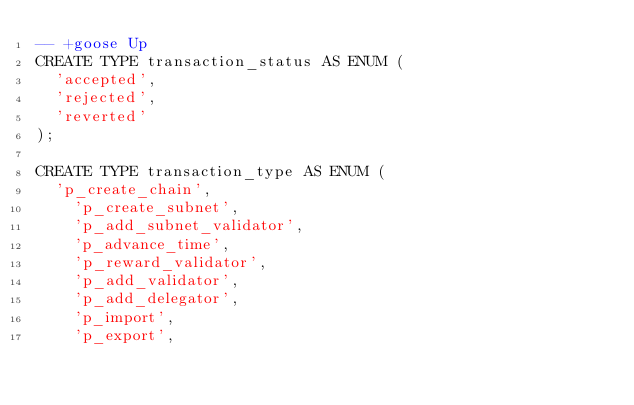Convert code to text. <code><loc_0><loc_0><loc_500><loc_500><_SQL_>-- +goose Up
CREATE TYPE transaction_status AS ENUM (
  'accepted',
  'rejected',
  'reverted'
);

CREATE TYPE transaction_type AS ENUM (
  'p_create_chain',
	'p_create_subnet',
	'p_add_subnet_validator',
	'p_advance_time',
	'p_reward_validator',
	'p_add_validator',
	'p_add_delegator',
	'p_import',
	'p_export',</code> 